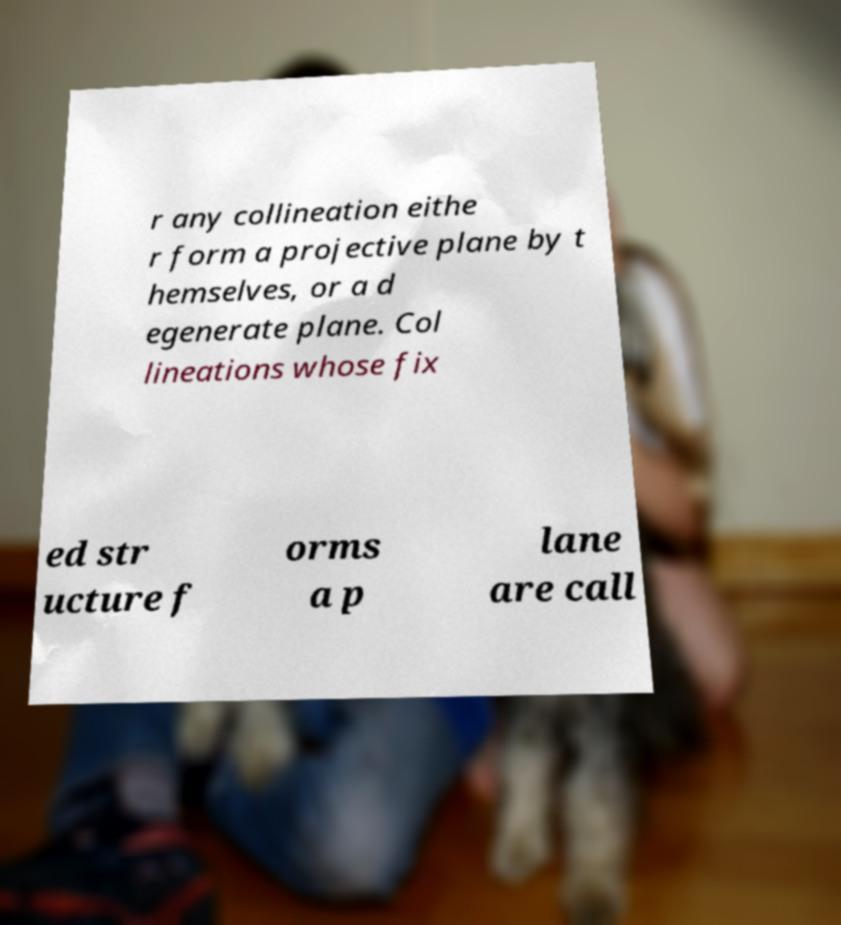Could you extract and type out the text from this image? r any collineation eithe r form a projective plane by t hemselves, or a d egenerate plane. Col lineations whose fix ed str ucture f orms a p lane are call 